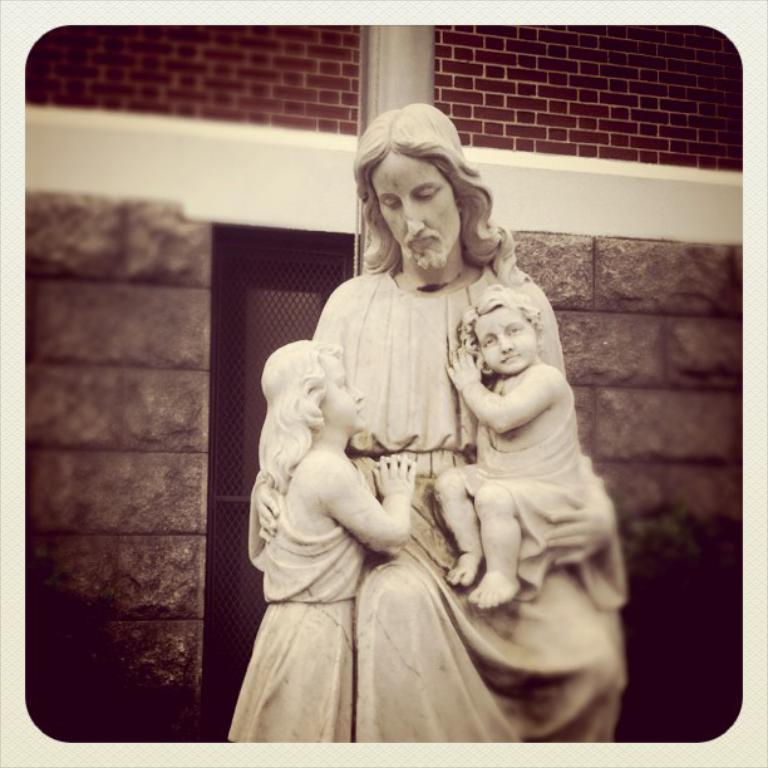Can you describe this image briefly? In the image we can see sculpture of a person and two children's. Here we can see the brick wall and the mesh. 